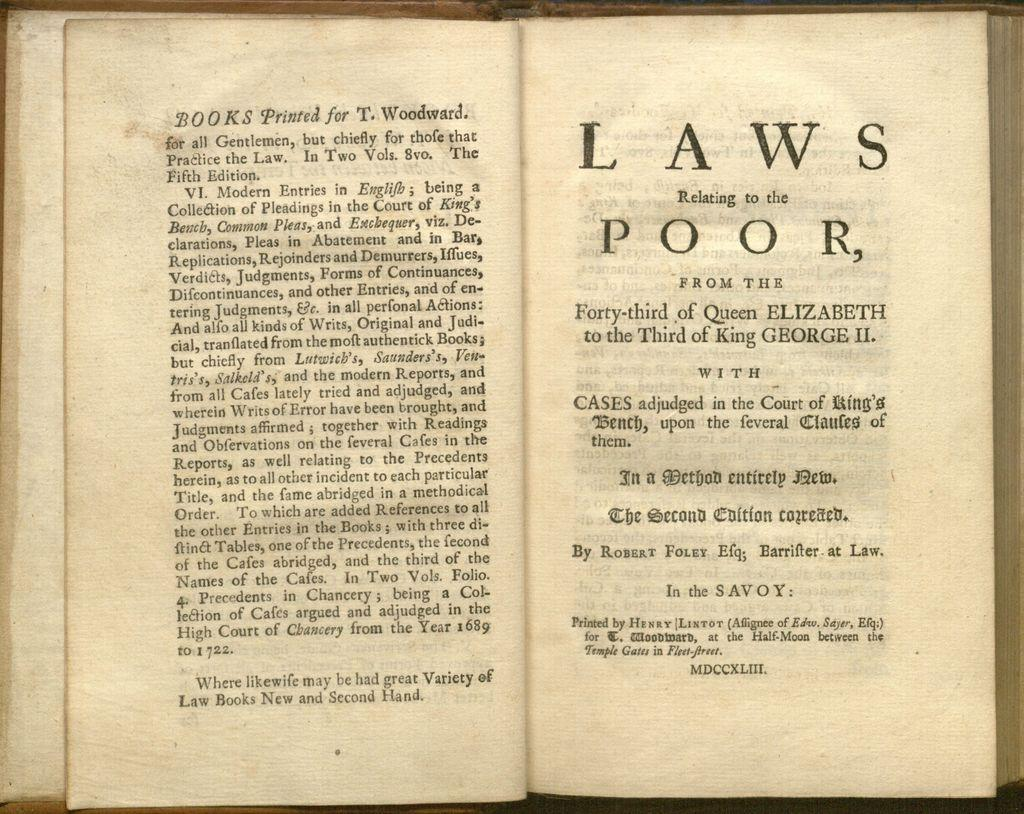<image>
Describe the image concisely. a book open to a page that is labeled 'laws relating to the poor' 